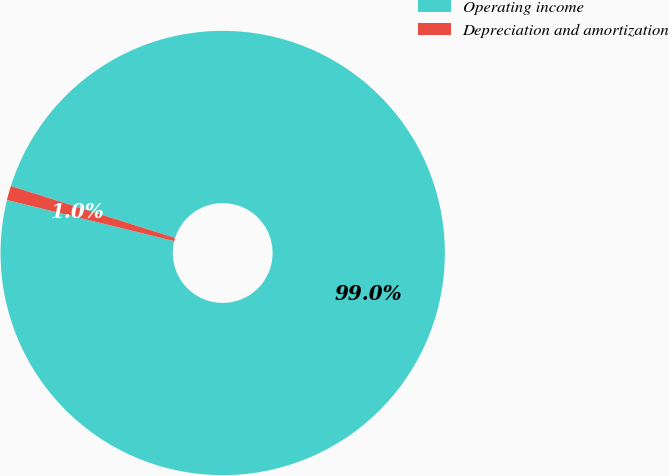Convert chart to OTSL. <chart><loc_0><loc_0><loc_500><loc_500><pie_chart><fcel>Operating income<fcel>Depreciation and amortization<nl><fcel>98.96%<fcel>1.04%<nl></chart> 